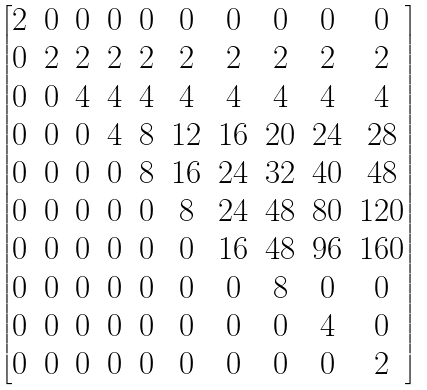Convert formula to latex. <formula><loc_0><loc_0><loc_500><loc_500>\begin{bmatrix} 2 & 0 & 0 & 0 & 0 & 0 & 0 & 0 & 0 & 0 \\ 0 & 2 & 2 & 2 & 2 & 2 & 2 & 2 & 2 & 2 \\ 0 & 0 & 4 & 4 & 4 & 4 & 4 & 4 & 4 & 4 \\ 0 & 0 & 0 & 4 & 8 & 1 2 & 1 6 & 2 0 & 2 4 & 2 8 \\ 0 & 0 & 0 & 0 & 8 & 1 6 & 2 4 & 3 2 & 4 0 & 4 8 \\ 0 & 0 & 0 & 0 & 0 & 8 & 2 4 & 4 8 & 8 0 & 1 2 0 \\ 0 & 0 & 0 & 0 & 0 & 0 & 1 6 & 4 8 & 9 6 & 1 6 0 \\ 0 & 0 & 0 & 0 & 0 & 0 & 0 & 8 & 0 & 0 \\ 0 & 0 & 0 & 0 & 0 & 0 & 0 & 0 & 4 & 0 \\ 0 & 0 & 0 & 0 & 0 & 0 & 0 & 0 & 0 & 2 \end{bmatrix}</formula> 